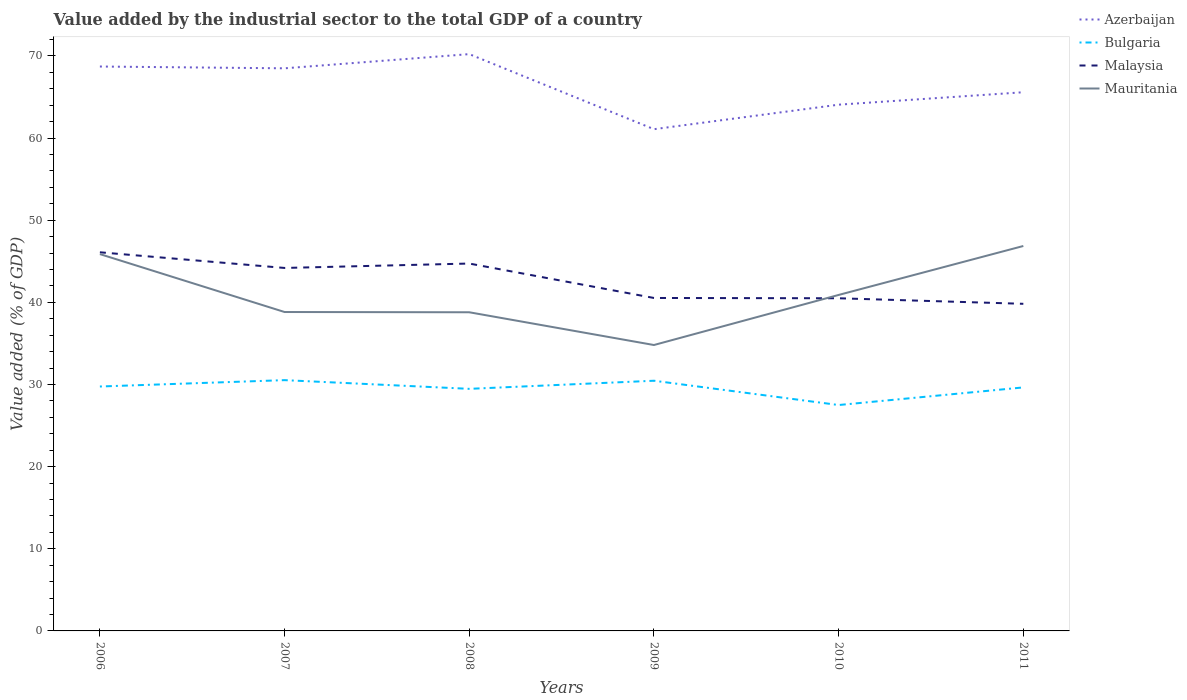How many different coloured lines are there?
Keep it short and to the point. 4. Does the line corresponding to Azerbaijan intersect with the line corresponding to Malaysia?
Make the answer very short. No. Across all years, what is the maximum value added by the industrial sector to the total GDP in Bulgaria?
Give a very brief answer. 27.5. In which year was the value added by the industrial sector to the total GDP in Mauritania maximum?
Your response must be concise. 2009. What is the total value added by the industrial sector to the total GDP in Malaysia in the graph?
Offer a terse response. 1.37. What is the difference between the highest and the second highest value added by the industrial sector to the total GDP in Malaysia?
Provide a short and direct response. 6.27. Are the values on the major ticks of Y-axis written in scientific E-notation?
Provide a short and direct response. No. Does the graph contain any zero values?
Your response must be concise. No. Does the graph contain grids?
Ensure brevity in your answer.  No. Where does the legend appear in the graph?
Provide a succinct answer. Top right. How are the legend labels stacked?
Keep it short and to the point. Vertical. What is the title of the graph?
Your response must be concise. Value added by the industrial sector to the total GDP of a country. Does "Mauritania" appear as one of the legend labels in the graph?
Provide a succinct answer. Yes. What is the label or title of the X-axis?
Offer a terse response. Years. What is the label or title of the Y-axis?
Offer a very short reply. Value added (% of GDP). What is the Value added (% of GDP) of Azerbaijan in 2006?
Your response must be concise. 68.71. What is the Value added (% of GDP) of Bulgaria in 2006?
Your response must be concise. 29.76. What is the Value added (% of GDP) of Malaysia in 2006?
Offer a very short reply. 46.1. What is the Value added (% of GDP) of Mauritania in 2006?
Give a very brief answer. 45.88. What is the Value added (% of GDP) in Azerbaijan in 2007?
Your response must be concise. 68.49. What is the Value added (% of GDP) of Bulgaria in 2007?
Provide a short and direct response. 30.53. What is the Value added (% of GDP) in Malaysia in 2007?
Keep it short and to the point. 44.19. What is the Value added (% of GDP) of Mauritania in 2007?
Your response must be concise. 38.82. What is the Value added (% of GDP) in Azerbaijan in 2008?
Ensure brevity in your answer.  70.22. What is the Value added (% of GDP) of Bulgaria in 2008?
Your answer should be very brief. 29.47. What is the Value added (% of GDP) of Malaysia in 2008?
Give a very brief answer. 44.73. What is the Value added (% of GDP) in Mauritania in 2008?
Provide a short and direct response. 38.8. What is the Value added (% of GDP) in Azerbaijan in 2009?
Provide a short and direct response. 61.08. What is the Value added (% of GDP) of Bulgaria in 2009?
Provide a short and direct response. 30.46. What is the Value added (% of GDP) in Malaysia in 2009?
Ensure brevity in your answer.  40.54. What is the Value added (% of GDP) of Mauritania in 2009?
Your answer should be compact. 34.81. What is the Value added (% of GDP) in Azerbaijan in 2010?
Your answer should be compact. 64.07. What is the Value added (% of GDP) of Bulgaria in 2010?
Your answer should be very brief. 27.5. What is the Value added (% of GDP) of Malaysia in 2010?
Offer a very short reply. 40.5. What is the Value added (% of GDP) in Mauritania in 2010?
Provide a short and direct response. 40.9. What is the Value added (% of GDP) in Azerbaijan in 2011?
Your response must be concise. 65.58. What is the Value added (% of GDP) in Bulgaria in 2011?
Your response must be concise. 29.65. What is the Value added (% of GDP) of Malaysia in 2011?
Your answer should be compact. 39.82. What is the Value added (% of GDP) in Mauritania in 2011?
Offer a terse response. 46.86. Across all years, what is the maximum Value added (% of GDP) in Azerbaijan?
Your answer should be very brief. 70.22. Across all years, what is the maximum Value added (% of GDP) in Bulgaria?
Your answer should be very brief. 30.53. Across all years, what is the maximum Value added (% of GDP) of Malaysia?
Give a very brief answer. 46.1. Across all years, what is the maximum Value added (% of GDP) of Mauritania?
Your answer should be compact. 46.86. Across all years, what is the minimum Value added (% of GDP) of Azerbaijan?
Your answer should be compact. 61.08. Across all years, what is the minimum Value added (% of GDP) in Bulgaria?
Your response must be concise. 27.5. Across all years, what is the minimum Value added (% of GDP) in Malaysia?
Offer a terse response. 39.82. Across all years, what is the minimum Value added (% of GDP) of Mauritania?
Provide a short and direct response. 34.81. What is the total Value added (% of GDP) of Azerbaijan in the graph?
Provide a short and direct response. 398.16. What is the total Value added (% of GDP) in Bulgaria in the graph?
Provide a succinct answer. 177.37. What is the total Value added (% of GDP) of Malaysia in the graph?
Keep it short and to the point. 255.87. What is the total Value added (% of GDP) of Mauritania in the graph?
Offer a terse response. 246.07. What is the difference between the Value added (% of GDP) in Azerbaijan in 2006 and that in 2007?
Your answer should be very brief. 0.22. What is the difference between the Value added (% of GDP) of Bulgaria in 2006 and that in 2007?
Offer a very short reply. -0.77. What is the difference between the Value added (% of GDP) of Malaysia in 2006 and that in 2007?
Your answer should be compact. 1.91. What is the difference between the Value added (% of GDP) in Mauritania in 2006 and that in 2007?
Offer a very short reply. 7.05. What is the difference between the Value added (% of GDP) in Azerbaijan in 2006 and that in 2008?
Keep it short and to the point. -1.51. What is the difference between the Value added (% of GDP) in Bulgaria in 2006 and that in 2008?
Your answer should be very brief. 0.28. What is the difference between the Value added (% of GDP) in Malaysia in 2006 and that in 2008?
Your answer should be very brief. 1.37. What is the difference between the Value added (% of GDP) of Mauritania in 2006 and that in 2008?
Ensure brevity in your answer.  7.08. What is the difference between the Value added (% of GDP) in Azerbaijan in 2006 and that in 2009?
Your response must be concise. 7.63. What is the difference between the Value added (% of GDP) of Bulgaria in 2006 and that in 2009?
Ensure brevity in your answer.  -0.7. What is the difference between the Value added (% of GDP) in Malaysia in 2006 and that in 2009?
Offer a very short reply. 5.56. What is the difference between the Value added (% of GDP) of Mauritania in 2006 and that in 2009?
Your answer should be compact. 11.07. What is the difference between the Value added (% of GDP) in Azerbaijan in 2006 and that in 2010?
Offer a terse response. 4.65. What is the difference between the Value added (% of GDP) in Bulgaria in 2006 and that in 2010?
Your answer should be very brief. 2.26. What is the difference between the Value added (% of GDP) of Malaysia in 2006 and that in 2010?
Give a very brief answer. 5.6. What is the difference between the Value added (% of GDP) in Mauritania in 2006 and that in 2010?
Your response must be concise. 4.97. What is the difference between the Value added (% of GDP) in Azerbaijan in 2006 and that in 2011?
Make the answer very short. 3.13. What is the difference between the Value added (% of GDP) in Bulgaria in 2006 and that in 2011?
Your answer should be very brief. 0.11. What is the difference between the Value added (% of GDP) in Malaysia in 2006 and that in 2011?
Offer a very short reply. 6.27. What is the difference between the Value added (% of GDP) of Mauritania in 2006 and that in 2011?
Give a very brief answer. -0.99. What is the difference between the Value added (% of GDP) in Azerbaijan in 2007 and that in 2008?
Your answer should be compact. -1.73. What is the difference between the Value added (% of GDP) of Bulgaria in 2007 and that in 2008?
Offer a terse response. 1.06. What is the difference between the Value added (% of GDP) of Malaysia in 2007 and that in 2008?
Your answer should be compact. -0.54. What is the difference between the Value added (% of GDP) of Mauritania in 2007 and that in 2008?
Your answer should be compact. 0.03. What is the difference between the Value added (% of GDP) in Azerbaijan in 2007 and that in 2009?
Make the answer very short. 7.41. What is the difference between the Value added (% of GDP) in Bulgaria in 2007 and that in 2009?
Provide a short and direct response. 0.07. What is the difference between the Value added (% of GDP) in Malaysia in 2007 and that in 2009?
Your response must be concise. 3.65. What is the difference between the Value added (% of GDP) in Mauritania in 2007 and that in 2009?
Provide a short and direct response. 4.02. What is the difference between the Value added (% of GDP) of Azerbaijan in 2007 and that in 2010?
Keep it short and to the point. 4.43. What is the difference between the Value added (% of GDP) of Bulgaria in 2007 and that in 2010?
Your response must be concise. 3.03. What is the difference between the Value added (% of GDP) of Malaysia in 2007 and that in 2010?
Give a very brief answer. 3.69. What is the difference between the Value added (% of GDP) of Mauritania in 2007 and that in 2010?
Offer a terse response. -2.08. What is the difference between the Value added (% of GDP) in Azerbaijan in 2007 and that in 2011?
Provide a short and direct response. 2.91. What is the difference between the Value added (% of GDP) of Bulgaria in 2007 and that in 2011?
Provide a succinct answer. 0.89. What is the difference between the Value added (% of GDP) of Malaysia in 2007 and that in 2011?
Make the answer very short. 4.37. What is the difference between the Value added (% of GDP) of Mauritania in 2007 and that in 2011?
Provide a short and direct response. -8.04. What is the difference between the Value added (% of GDP) in Azerbaijan in 2008 and that in 2009?
Make the answer very short. 9.14. What is the difference between the Value added (% of GDP) in Bulgaria in 2008 and that in 2009?
Offer a very short reply. -0.99. What is the difference between the Value added (% of GDP) of Malaysia in 2008 and that in 2009?
Make the answer very short. 4.19. What is the difference between the Value added (% of GDP) of Mauritania in 2008 and that in 2009?
Offer a very short reply. 3.99. What is the difference between the Value added (% of GDP) in Azerbaijan in 2008 and that in 2010?
Provide a succinct answer. 6.15. What is the difference between the Value added (% of GDP) of Bulgaria in 2008 and that in 2010?
Ensure brevity in your answer.  1.97. What is the difference between the Value added (% of GDP) in Malaysia in 2008 and that in 2010?
Give a very brief answer. 4.23. What is the difference between the Value added (% of GDP) in Mauritania in 2008 and that in 2010?
Provide a succinct answer. -2.11. What is the difference between the Value added (% of GDP) in Azerbaijan in 2008 and that in 2011?
Keep it short and to the point. 4.64. What is the difference between the Value added (% of GDP) of Bulgaria in 2008 and that in 2011?
Make the answer very short. -0.17. What is the difference between the Value added (% of GDP) of Malaysia in 2008 and that in 2011?
Your response must be concise. 4.9. What is the difference between the Value added (% of GDP) of Mauritania in 2008 and that in 2011?
Provide a short and direct response. -8.07. What is the difference between the Value added (% of GDP) of Azerbaijan in 2009 and that in 2010?
Provide a succinct answer. -2.98. What is the difference between the Value added (% of GDP) in Bulgaria in 2009 and that in 2010?
Provide a short and direct response. 2.96. What is the difference between the Value added (% of GDP) in Malaysia in 2009 and that in 2010?
Offer a very short reply. 0.04. What is the difference between the Value added (% of GDP) of Mauritania in 2009 and that in 2010?
Provide a succinct answer. -6.1. What is the difference between the Value added (% of GDP) in Azerbaijan in 2009 and that in 2011?
Your response must be concise. -4.5. What is the difference between the Value added (% of GDP) of Bulgaria in 2009 and that in 2011?
Offer a very short reply. 0.81. What is the difference between the Value added (% of GDP) in Malaysia in 2009 and that in 2011?
Your answer should be very brief. 0.71. What is the difference between the Value added (% of GDP) of Mauritania in 2009 and that in 2011?
Your response must be concise. -12.05. What is the difference between the Value added (% of GDP) of Azerbaijan in 2010 and that in 2011?
Your response must be concise. -1.51. What is the difference between the Value added (% of GDP) of Bulgaria in 2010 and that in 2011?
Your answer should be very brief. -2.14. What is the difference between the Value added (% of GDP) in Malaysia in 2010 and that in 2011?
Keep it short and to the point. 0.67. What is the difference between the Value added (% of GDP) of Mauritania in 2010 and that in 2011?
Make the answer very short. -5.96. What is the difference between the Value added (% of GDP) of Azerbaijan in 2006 and the Value added (% of GDP) of Bulgaria in 2007?
Make the answer very short. 38.18. What is the difference between the Value added (% of GDP) in Azerbaijan in 2006 and the Value added (% of GDP) in Malaysia in 2007?
Keep it short and to the point. 24.52. What is the difference between the Value added (% of GDP) of Azerbaijan in 2006 and the Value added (% of GDP) of Mauritania in 2007?
Your response must be concise. 29.89. What is the difference between the Value added (% of GDP) of Bulgaria in 2006 and the Value added (% of GDP) of Malaysia in 2007?
Ensure brevity in your answer.  -14.43. What is the difference between the Value added (% of GDP) of Bulgaria in 2006 and the Value added (% of GDP) of Mauritania in 2007?
Keep it short and to the point. -9.07. What is the difference between the Value added (% of GDP) in Malaysia in 2006 and the Value added (% of GDP) in Mauritania in 2007?
Your answer should be compact. 7.27. What is the difference between the Value added (% of GDP) of Azerbaijan in 2006 and the Value added (% of GDP) of Bulgaria in 2008?
Keep it short and to the point. 39.24. What is the difference between the Value added (% of GDP) of Azerbaijan in 2006 and the Value added (% of GDP) of Malaysia in 2008?
Provide a succinct answer. 23.99. What is the difference between the Value added (% of GDP) in Azerbaijan in 2006 and the Value added (% of GDP) in Mauritania in 2008?
Your response must be concise. 29.92. What is the difference between the Value added (% of GDP) in Bulgaria in 2006 and the Value added (% of GDP) in Malaysia in 2008?
Keep it short and to the point. -14.97. What is the difference between the Value added (% of GDP) in Bulgaria in 2006 and the Value added (% of GDP) in Mauritania in 2008?
Ensure brevity in your answer.  -9.04. What is the difference between the Value added (% of GDP) in Malaysia in 2006 and the Value added (% of GDP) in Mauritania in 2008?
Keep it short and to the point. 7.3. What is the difference between the Value added (% of GDP) of Azerbaijan in 2006 and the Value added (% of GDP) of Bulgaria in 2009?
Ensure brevity in your answer.  38.25. What is the difference between the Value added (% of GDP) in Azerbaijan in 2006 and the Value added (% of GDP) in Malaysia in 2009?
Ensure brevity in your answer.  28.18. What is the difference between the Value added (% of GDP) of Azerbaijan in 2006 and the Value added (% of GDP) of Mauritania in 2009?
Give a very brief answer. 33.9. What is the difference between the Value added (% of GDP) of Bulgaria in 2006 and the Value added (% of GDP) of Malaysia in 2009?
Your answer should be very brief. -10.78. What is the difference between the Value added (% of GDP) in Bulgaria in 2006 and the Value added (% of GDP) in Mauritania in 2009?
Keep it short and to the point. -5.05. What is the difference between the Value added (% of GDP) of Malaysia in 2006 and the Value added (% of GDP) of Mauritania in 2009?
Make the answer very short. 11.29. What is the difference between the Value added (% of GDP) in Azerbaijan in 2006 and the Value added (% of GDP) in Bulgaria in 2010?
Your response must be concise. 41.21. What is the difference between the Value added (% of GDP) of Azerbaijan in 2006 and the Value added (% of GDP) of Malaysia in 2010?
Your answer should be compact. 28.21. What is the difference between the Value added (% of GDP) of Azerbaijan in 2006 and the Value added (% of GDP) of Mauritania in 2010?
Keep it short and to the point. 27.81. What is the difference between the Value added (% of GDP) in Bulgaria in 2006 and the Value added (% of GDP) in Malaysia in 2010?
Your response must be concise. -10.74. What is the difference between the Value added (% of GDP) in Bulgaria in 2006 and the Value added (% of GDP) in Mauritania in 2010?
Provide a succinct answer. -11.15. What is the difference between the Value added (% of GDP) of Malaysia in 2006 and the Value added (% of GDP) of Mauritania in 2010?
Your answer should be very brief. 5.19. What is the difference between the Value added (% of GDP) of Azerbaijan in 2006 and the Value added (% of GDP) of Bulgaria in 2011?
Ensure brevity in your answer.  39.07. What is the difference between the Value added (% of GDP) of Azerbaijan in 2006 and the Value added (% of GDP) of Malaysia in 2011?
Make the answer very short. 28.89. What is the difference between the Value added (% of GDP) in Azerbaijan in 2006 and the Value added (% of GDP) in Mauritania in 2011?
Your answer should be compact. 21.85. What is the difference between the Value added (% of GDP) of Bulgaria in 2006 and the Value added (% of GDP) of Malaysia in 2011?
Make the answer very short. -10.07. What is the difference between the Value added (% of GDP) of Bulgaria in 2006 and the Value added (% of GDP) of Mauritania in 2011?
Give a very brief answer. -17.11. What is the difference between the Value added (% of GDP) of Malaysia in 2006 and the Value added (% of GDP) of Mauritania in 2011?
Provide a short and direct response. -0.77. What is the difference between the Value added (% of GDP) of Azerbaijan in 2007 and the Value added (% of GDP) of Bulgaria in 2008?
Offer a very short reply. 39.02. What is the difference between the Value added (% of GDP) of Azerbaijan in 2007 and the Value added (% of GDP) of Malaysia in 2008?
Offer a very short reply. 23.77. What is the difference between the Value added (% of GDP) in Azerbaijan in 2007 and the Value added (% of GDP) in Mauritania in 2008?
Offer a terse response. 29.7. What is the difference between the Value added (% of GDP) in Bulgaria in 2007 and the Value added (% of GDP) in Malaysia in 2008?
Provide a short and direct response. -14.2. What is the difference between the Value added (% of GDP) of Bulgaria in 2007 and the Value added (% of GDP) of Mauritania in 2008?
Make the answer very short. -8.26. What is the difference between the Value added (% of GDP) of Malaysia in 2007 and the Value added (% of GDP) of Mauritania in 2008?
Keep it short and to the point. 5.39. What is the difference between the Value added (% of GDP) of Azerbaijan in 2007 and the Value added (% of GDP) of Bulgaria in 2009?
Your response must be concise. 38.04. What is the difference between the Value added (% of GDP) in Azerbaijan in 2007 and the Value added (% of GDP) in Malaysia in 2009?
Keep it short and to the point. 27.96. What is the difference between the Value added (% of GDP) in Azerbaijan in 2007 and the Value added (% of GDP) in Mauritania in 2009?
Keep it short and to the point. 33.69. What is the difference between the Value added (% of GDP) of Bulgaria in 2007 and the Value added (% of GDP) of Malaysia in 2009?
Ensure brevity in your answer.  -10. What is the difference between the Value added (% of GDP) in Bulgaria in 2007 and the Value added (% of GDP) in Mauritania in 2009?
Offer a terse response. -4.28. What is the difference between the Value added (% of GDP) of Malaysia in 2007 and the Value added (% of GDP) of Mauritania in 2009?
Your response must be concise. 9.38. What is the difference between the Value added (% of GDP) of Azerbaijan in 2007 and the Value added (% of GDP) of Bulgaria in 2010?
Ensure brevity in your answer.  40.99. What is the difference between the Value added (% of GDP) of Azerbaijan in 2007 and the Value added (% of GDP) of Malaysia in 2010?
Your answer should be compact. 28. What is the difference between the Value added (% of GDP) in Azerbaijan in 2007 and the Value added (% of GDP) in Mauritania in 2010?
Offer a terse response. 27.59. What is the difference between the Value added (% of GDP) in Bulgaria in 2007 and the Value added (% of GDP) in Malaysia in 2010?
Offer a very short reply. -9.97. What is the difference between the Value added (% of GDP) of Bulgaria in 2007 and the Value added (% of GDP) of Mauritania in 2010?
Your answer should be very brief. -10.37. What is the difference between the Value added (% of GDP) in Malaysia in 2007 and the Value added (% of GDP) in Mauritania in 2010?
Your response must be concise. 3.29. What is the difference between the Value added (% of GDP) of Azerbaijan in 2007 and the Value added (% of GDP) of Bulgaria in 2011?
Keep it short and to the point. 38.85. What is the difference between the Value added (% of GDP) in Azerbaijan in 2007 and the Value added (% of GDP) in Malaysia in 2011?
Offer a very short reply. 28.67. What is the difference between the Value added (% of GDP) of Azerbaijan in 2007 and the Value added (% of GDP) of Mauritania in 2011?
Provide a short and direct response. 21.63. What is the difference between the Value added (% of GDP) of Bulgaria in 2007 and the Value added (% of GDP) of Malaysia in 2011?
Your answer should be compact. -9.29. What is the difference between the Value added (% of GDP) in Bulgaria in 2007 and the Value added (% of GDP) in Mauritania in 2011?
Offer a terse response. -16.33. What is the difference between the Value added (% of GDP) in Malaysia in 2007 and the Value added (% of GDP) in Mauritania in 2011?
Provide a succinct answer. -2.67. What is the difference between the Value added (% of GDP) of Azerbaijan in 2008 and the Value added (% of GDP) of Bulgaria in 2009?
Give a very brief answer. 39.76. What is the difference between the Value added (% of GDP) in Azerbaijan in 2008 and the Value added (% of GDP) in Malaysia in 2009?
Ensure brevity in your answer.  29.69. What is the difference between the Value added (% of GDP) in Azerbaijan in 2008 and the Value added (% of GDP) in Mauritania in 2009?
Provide a short and direct response. 35.41. What is the difference between the Value added (% of GDP) of Bulgaria in 2008 and the Value added (% of GDP) of Malaysia in 2009?
Make the answer very short. -11.06. What is the difference between the Value added (% of GDP) in Bulgaria in 2008 and the Value added (% of GDP) in Mauritania in 2009?
Ensure brevity in your answer.  -5.34. What is the difference between the Value added (% of GDP) of Malaysia in 2008 and the Value added (% of GDP) of Mauritania in 2009?
Make the answer very short. 9.92. What is the difference between the Value added (% of GDP) in Azerbaijan in 2008 and the Value added (% of GDP) in Bulgaria in 2010?
Offer a terse response. 42.72. What is the difference between the Value added (% of GDP) in Azerbaijan in 2008 and the Value added (% of GDP) in Malaysia in 2010?
Offer a terse response. 29.72. What is the difference between the Value added (% of GDP) of Azerbaijan in 2008 and the Value added (% of GDP) of Mauritania in 2010?
Provide a short and direct response. 29.32. What is the difference between the Value added (% of GDP) of Bulgaria in 2008 and the Value added (% of GDP) of Malaysia in 2010?
Provide a succinct answer. -11.03. What is the difference between the Value added (% of GDP) in Bulgaria in 2008 and the Value added (% of GDP) in Mauritania in 2010?
Your response must be concise. -11.43. What is the difference between the Value added (% of GDP) of Malaysia in 2008 and the Value added (% of GDP) of Mauritania in 2010?
Ensure brevity in your answer.  3.82. What is the difference between the Value added (% of GDP) of Azerbaijan in 2008 and the Value added (% of GDP) of Bulgaria in 2011?
Your response must be concise. 40.58. What is the difference between the Value added (% of GDP) of Azerbaijan in 2008 and the Value added (% of GDP) of Malaysia in 2011?
Keep it short and to the point. 30.4. What is the difference between the Value added (% of GDP) in Azerbaijan in 2008 and the Value added (% of GDP) in Mauritania in 2011?
Your answer should be compact. 23.36. What is the difference between the Value added (% of GDP) of Bulgaria in 2008 and the Value added (% of GDP) of Malaysia in 2011?
Provide a short and direct response. -10.35. What is the difference between the Value added (% of GDP) in Bulgaria in 2008 and the Value added (% of GDP) in Mauritania in 2011?
Provide a short and direct response. -17.39. What is the difference between the Value added (% of GDP) of Malaysia in 2008 and the Value added (% of GDP) of Mauritania in 2011?
Make the answer very short. -2.14. What is the difference between the Value added (% of GDP) in Azerbaijan in 2009 and the Value added (% of GDP) in Bulgaria in 2010?
Provide a succinct answer. 33.58. What is the difference between the Value added (% of GDP) in Azerbaijan in 2009 and the Value added (% of GDP) in Malaysia in 2010?
Offer a terse response. 20.58. What is the difference between the Value added (% of GDP) in Azerbaijan in 2009 and the Value added (% of GDP) in Mauritania in 2010?
Your answer should be very brief. 20.18. What is the difference between the Value added (% of GDP) of Bulgaria in 2009 and the Value added (% of GDP) of Malaysia in 2010?
Make the answer very short. -10.04. What is the difference between the Value added (% of GDP) of Bulgaria in 2009 and the Value added (% of GDP) of Mauritania in 2010?
Your answer should be compact. -10.44. What is the difference between the Value added (% of GDP) of Malaysia in 2009 and the Value added (% of GDP) of Mauritania in 2010?
Your answer should be compact. -0.37. What is the difference between the Value added (% of GDP) in Azerbaijan in 2009 and the Value added (% of GDP) in Bulgaria in 2011?
Make the answer very short. 31.44. What is the difference between the Value added (% of GDP) in Azerbaijan in 2009 and the Value added (% of GDP) in Malaysia in 2011?
Your answer should be compact. 21.26. What is the difference between the Value added (% of GDP) of Azerbaijan in 2009 and the Value added (% of GDP) of Mauritania in 2011?
Offer a terse response. 14.22. What is the difference between the Value added (% of GDP) in Bulgaria in 2009 and the Value added (% of GDP) in Malaysia in 2011?
Make the answer very short. -9.37. What is the difference between the Value added (% of GDP) of Bulgaria in 2009 and the Value added (% of GDP) of Mauritania in 2011?
Make the answer very short. -16.4. What is the difference between the Value added (% of GDP) in Malaysia in 2009 and the Value added (% of GDP) in Mauritania in 2011?
Offer a terse response. -6.33. What is the difference between the Value added (% of GDP) of Azerbaijan in 2010 and the Value added (% of GDP) of Bulgaria in 2011?
Your answer should be compact. 34.42. What is the difference between the Value added (% of GDP) of Azerbaijan in 2010 and the Value added (% of GDP) of Malaysia in 2011?
Offer a very short reply. 24.24. What is the difference between the Value added (% of GDP) in Azerbaijan in 2010 and the Value added (% of GDP) in Mauritania in 2011?
Make the answer very short. 17.2. What is the difference between the Value added (% of GDP) of Bulgaria in 2010 and the Value added (% of GDP) of Malaysia in 2011?
Ensure brevity in your answer.  -12.32. What is the difference between the Value added (% of GDP) of Bulgaria in 2010 and the Value added (% of GDP) of Mauritania in 2011?
Your response must be concise. -19.36. What is the difference between the Value added (% of GDP) in Malaysia in 2010 and the Value added (% of GDP) in Mauritania in 2011?
Keep it short and to the point. -6.36. What is the average Value added (% of GDP) in Azerbaijan per year?
Your answer should be compact. 66.36. What is the average Value added (% of GDP) in Bulgaria per year?
Give a very brief answer. 29.56. What is the average Value added (% of GDP) in Malaysia per year?
Offer a very short reply. 42.65. What is the average Value added (% of GDP) in Mauritania per year?
Give a very brief answer. 41.01. In the year 2006, what is the difference between the Value added (% of GDP) of Azerbaijan and Value added (% of GDP) of Bulgaria?
Make the answer very short. 38.96. In the year 2006, what is the difference between the Value added (% of GDP) of Azerbaijan and Value added (% of GDP) of Malaysia?
Provide a short and direct response. 22.62. In the year 2006, what is the difference between the Value added (% of GDP) in Azerbaijan and Value added (% of GDP) in Mauritania?
Offer a terse response. 22.84. In the year 2006, what is the difference between the Value added (% of GDP) in Bulgaria and Value added (% of GDP) in Malaysia?
Provide a succinct answer. -16.34. In the year 2006, what is the difference between the Value added (% of GDP) in Bulgaria and Value added (% of GDP) in Mauritania?
Your answer should be very brief. -16.12. In the year 2006, what is the difference between the Value added (% of GDP) of Malaysia and Value added (% of GDP) of Mauritania?
Your response must be concise. 0.22. In the year 2007, what is the difference between the Value added (% of GDP) of Azerbaijan and Value added (% of GDP) of Bulgaria?
Provide a short and direct response. 37.96. In the year 2007, what is the difference between the Value added (% of GDP) in Azerbaijan and Value added (% of GDP) in Malaysia?
Offer a terse response. 24.3. In the year 2007, what is the difference between the Value added (% of GDP) in Azerbaijan and Value added (% of GDP) in Mauritania?
Provide a short and direct response. 29.67. In the year 2007, what is the difference between the Value added (% of GDP) in Bulgaria and Value added (% of GDP) in Malaysia?
Your answer should be very brief. -13.66. In the year 2007, what is the difference between the Value added (% of GDP) of Bulgaria and Value added (% of GDP) of Mauritania?
Your answer should be compact. -8.29. In the year 2007, what is the difference between the Value added (% of GDP) in Malaysia and Value added (% of GDP) in Mauritania?
Provide a succinct answer. 5.37. In the year 2008, what is the difference between the Value added (% of GDP) in Azerbaijan and Value added (% of GDP) in Bulgaria?
Provide a short and direct response. 40.75. In the year 2008, what is the difference between the Value added (% of GDP) of Azerbaijan and Value added (% of GDP) of Malaysia?
Offer a terse response. 25.5. In the year 2008, what is the difference between the Value added (% of GDP) of Azerbaijan and Value added (% of GDP) of Mauritania?
Give a very brief answer. 31.43. In the year 2008, what is the difference between the Value added (% of GDP) in Bulgaria and Value added (% of GDP) in Malaysia?
Provide a short and direct response. -15.25. In the year 2008, what is the difference between the Value added (% of GDP) in Bulgaria and Value added (% of GDP) in Mauritania?
Provide a short and direct response. -9.32. In the year 2008, what is the difference between the Value added (% of GDP) of Malaysia and Value added (% of GDP) of Mauritania?
Give a very brief answer. 5.93. In the year 2009, what is the difference between the Value added (% of GDP) of Azerbaijan and Value added (% of GDP) of Bulgaria?
Your answer should be very brief. 30.62. In the year 2009, what is the difference between the Value added (% of GDP) of Azerbaijan and Value added (% of GDP) of Malaysia?
Make the answer very short. 20.55. In the year 2009, what is the difference between the Value added (% of GDP) in Azerbaijan and Value added (% of GDP) in Mauritania?
Provide a short and direct response. 26.27. In the year 2009, what is the difference between the Value added (% of GDP) in Bulgaria and Value added (% of GDP) in Malaysia?
Keep it short and to the point. -10.08. In the year 2009, what is the difference between the Value added (% of GDP) of Bulgaria and Value added (% of GDP) of Mauritania?
Offer a terse response. -4.35. In the year 2009, what is the difference between the Value added (% of GDP) in Malaysia and Value added (% of GDP) in Mauritania?
Provide a short and direct response. 5.73. In the year 2010, what is the difference between the Value added (% of GDP) in Azerbaijan and Value added (% of GDP) in Bulgaria?
Keep it short and to the point. 36.57. In the year 2010, what is the difference between the Value added (% of GDP) of Azerbaijan and Value added (% of GDP) of Malaysia?
Make the answer very short. 23.57. In the year 2010, what is the difference between the Value added (% of GDP) in Azerbaijan and Value added (% of GDP) in Mauritania?
Ensure brevity in your answer.  23.16. In the year 2010, what is the difference between the Value added (% of GDP) of Bulgaria and Value added (% of GDP) of Malaysia?
Your response must be concise. -13. In the year 2010, what is the difference between the Value added (% of GDP) in Bulgaria and Value added (% of GDP) in Mauritania?
Offer a very short reply. -13.4. In the year 2010, what is the difference between the Value added (% of GDP) in Malaysia and Value added (% of GDP) in Mauritania?
Your answer should be very brief. -0.4. In the year 2011, what is the difference between the Value added (% of GDP) of Azerbaijan and Value added (% of GDP) of Bulgaria?
Your answer should be compact. 35.94. In the year 2011, what is the difference between the Value added (% of GDP) in Azerbaijan and Value added (% of GDP) in Malaysia?
Provide a succinct answer. 25.76. In the year 2011, what is the difference between the Value added (% of GDP) of Azerbaijan and Value added (% of GDP) of Mauritania?
Make the answer very short. 18.72. In the year 2011, what is the difference between the Value added (% of GDP) in Bulgaria and Value added (% of GDP) in Malaysia?
Make the answer very short. -10.18. In the year 2011, what is the difference between the Value added (% of GDP) in Bulgaria and Value added (% of GDP) in Mauritania?
Offer a very short reply. -17.22. In the year 2011, what is the difference between the Value added (% of GDP) of Malaysia and Value added (% of GDP) of Mauritania?
Give a very brief answer. -7.04. What is the ratio of the Value added (% of GDP) in Bulgaria in 2006 to that in 2007?
Your response must be concise. 0.97. What is the ratio of the Value added (% of GDP) in Malaysia in 2006 to that in 2007?
Your answer should be very brief. 1.04. What is the ratio of the Value added (% of GDP) in Mauritania in 2006 to that in 2007?
Your answer should be compact. 1.18. What is the ratio of the Value added (% of GDP) in Azerbaijan in 2006 to that in 2008?
Your answer should be compact. 0.98. What is the ratio of the Value added (% of GDP) in Bulgaria in 2006 to that in 2008?
Make the answer very short. 1.01. What is the ratio of the Value added (% of GDP) in Malaysia in 2006 to that in 2008?
Offer a terse response. 1.03. What is the ratio of the Value added (% of GDP) of Mauritania in 2006 to that in 2008?
Offer a very short reply. 1.18. What is the ratio of the Value added (% of GDP) in Azerbaijan in 2006 to that in 2009?
Provide a succinct answer. 1.12. What is the ratio of the Value added (% of GDP) in Bulgaria in 2006 to that in 2009?
Your response must be concise. 0.98. What is the ratio of the Value added (% of GDP) of Malaysia in 2006 to that in 2009?
Offer a very short reply. 1.14. What is the ratio of the Value added (% of GDP) in Mauritania in 2006 to that in 2009?
Offer a very short reply. 1.32. What is the ratio of the Value added (% of GDP) of Azerbaijan in 2006 to that in 2010?
Offer a very short reply. 1.07. What is the ratio of the Value added (% of GDP) in Bulgaria in 2006 to that in 2010?
Ensure brevity in your answer.  1.08. What is the ratio of the Value added (% of GDP) of Malaysia in 2006 to that in 2010?
Offer a terse response. 1.14. What is the ratio of the Value added (% of GDP) of Mauritania in 2006 to that in 2010?
Give a very brief answer. 1.12. What is the ratio of the Value added (% of GDP) in Azerbaijan in 2006 to that in 2011?
Provide a short and direct response. 1.05. What is the ratio of the Value added (% of GDP) in Bulgaria in 2006 to that in 2011?
Offer a very short reply. 1. What is the ratio of the Value added (% of GDP) of Malaysia in 2006 to that in 2011?
Offer a very short reply. 1.16. What is the ratio of the Value added (% of GDP) of Mauritania in 2006 to that in 2011?
Your answer should be very brief. 0.98. What is the ratio of the Value added (% of GDP) in Azerbaijan in 2007 to that in 2008?
Provide a short and direct response. 0.98. What is the ratio of the Value added (% of GDP) of Bulgaria in 2007 to that in 2008?
Make the answer very short. 1.04. What is the ratio of the Value added (% of GDP) of Malaysia in 2007 to that in 2008?
Ensure brevity in your answer.  0.99. What is the ratio of the Value added (% of GDP) of Mauritania in 2007 to that in 2008?
Ensure brevity in your answer.  1. What is the ratio of the Value added (% of GDP) in Azerbaijan in 2007 to that in 2009?
Give a very brief answer. 1.12. What is the ratio of the Value added (% of GDP) of Bulgaria in 2007 to that in 2009?
Make the answer very short. 1. What is the ratio of the Value added (% of GDP) in Malaysia in 2007 to that in 2009?
Provide a short and direct response. 1.09. What is the ratio of the Value added (% of GDP) of Mauritania in 2007 to that in 2009?
Provide a succinct answer. 1.12. What is the ratio of the Value added (% of GDP) of Azerbaijan in 2007 to that in 2010?
Make the answer very short. 1.07. What is the ratio of the Value added (% of GDP) of Bulgaria in 2007 to that in 2010?
Ensure brevity in your answer.  1.11. What is the ratio of the Value added (% of GDP) of Malaysia in 2007 to that in 2010?
Your answer should be compact. 1.09. What is the ratio of the Value added (% of GDP) in Mauritania in 2007 to that in 2010?
Give a very brief answer. 0.95. What is the ratio of the Value added (% of GDP) in Azerbaijan in 2007 to that in 2011?
Provide a succinct answer. 1.04. What is the ratio of the Value added (% of GDP) in Bulgaria in 2007 to that in 2011?
Provide a succinct answer. 1.03. What is the ratio of the Value added (% of GDP) of Malaysia in 2007 to that in 2011?
Your answer should be compact. 1.11. What is the ratio of the Value added (% of GDP) of Mauritania in 2007 to that in 2011?
Your response must be concise. 0.83. What is the ratio of the Value added (% of GDP) in Azerbaijan in 2008 to that in 2009?
Make the answer very short. 1.15. What is the ratio of the Value added (% of GDP) of Bulgaria in 2008 to that in 2009?
Give a very brief answer. 0.97. What is the ratio of the Value added (% of GDP) in Malaysia in 2008 to that in 2009?
Offer a terse response. 1.1. What is the ratio of the Value added (% of GDP) of Mauritania in 2008 to that in 2009?
Give a very brief answer. 1.11. What is the ratio of the Value added (% of GDP) of Azerbaijan in 2008 to that in 2010?
Give a very brief answer. 1.1. What is the ratio of the Value added (% of GDP) of Bulgaria in 2008 to that in 2010?
Give a very brief answer. 1.07. What is the ratio of the Value added (% of GDP) in Malaysia in 2008 to that in 2010?
Ensure brevity in your answer.  1.1. What is the ratio of the Value added (% of GDP) of Mauritania in 2008 to that in 2010?
Provide a succinct answer. 0.95. What is the ratio of the Value added (% of GDP) in Azerbaijan in 2008 to that in 2011?
Your answer should be compact. 1.07. What is the ratio of the Value added (% of GDP) in Malaysia in 2008 to that in 2011?
Your answer should be very brief. 1.12. What is the ratio of the Value added (% of GDP) of Mauritania in 2008 to that in 2011?
Keep it short and to the point. 0.83. What is the ratio of the Value added (% of GDP) of Azerbaijan in 2009 to that in 2010?
Your response must be concise. 0.95. What is the ratio of the Value added (% of GDP) in Bulgaria in 2009 to that in 2010?
Give a very brief answer. 1.11. What is the ratio of the Value added (% of GDP) in Malaysia in 2009 to that in 2010?
Offer a terse response. 1. What is the ratio of the Value added (% of GDP) of Mauritania in 2009 to that in 2010?
Your answer should be very brief. 0.85. What is the ratio of the Value added (% of GDP) of Azerbaijan in 2009 to that in 2011?
Your answer should be compact. 0.93. What is the ratio of the Value added (% of GDP) in Bulgaria in 2009 to that in 2011?
Keep it short and to the point. 1.03. What is the ratio of the Value added (% of GDP) in Malaysia in 2009 to that in 2011?
Offer a terse response. 1.02. What is the ratio of the Value added (% of GDP) of Mauritania in 2009 to that in 2011?
Provide a short and direct response. 0.74. What is the ratio of the Value added (% of GDP) in Azerbaijan in 2010 to that in 2011?
Your answer should be very brief. 0.98. What is the ratio of the Value added (% of GDP) in Bulgaria in 2010 to that in 2011?
Your answer should be compact. 0.93. What is the ratio of the Value added (% of GDP) in Malaysia in 2010 to that in 2011?
Give a very brief answer. 1.02. What is the ratio of the Value added (% of GDP) in Mauritania in 2010 to that in 2011?
Keep it short and to the point. 0.87. What is the difference between the highest and the second highest Value added (% of GDP) in Azerbaijan?
Offer a very short reply. 1.51. What is the difference between the highest and the second highest Value added (% of GDP) in Bulgaria?
Your response must be concise. 0.07. What is the difference between the highest and the second highest Value added (% of GDP) in Malaysia?
Provide a short and direct response. 1.37. What is the difference between the highest and the second highest Value added (% of GDP) in Mauritania?
Keep it short and to the point. 0.99. What is the difference between the highest and the lowest Value added (% of GDP) in Azerbaijan?
Offer a terse response. 9.14. What is the difference between the highest and the lowest Value added (% of GDP) of Bulgaria?
Your answer should be compact. 3.03. What is the difference between the highest and the lowest Value added (% of GDP) of Malaysia?
Ensure brevity in your answer.  6.27. What is the difference between the highest and the lowest Value added (% of GDP) of Mauritania?
Your answer should be very brief. 12.05. 